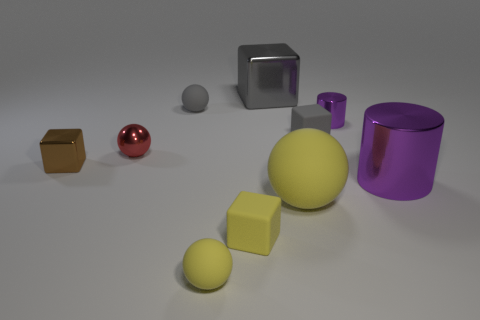Subtract all brown cubes. How many cubes are left? 3 Subtract all blue blocks. Subtract all purple balls. How many blocks are left? 4 Subtract all spheres. How many objects are left? 6 Subtract 0 yellow cylinders. How many objects are left? 10 Subtract all gray matte spheres. Subtract all big gray cubes. How many objects are left? 8 Add 9 gray spheres. How many gray spheres are left? 10 Add 6 red balls. How many red balls exist? 7 